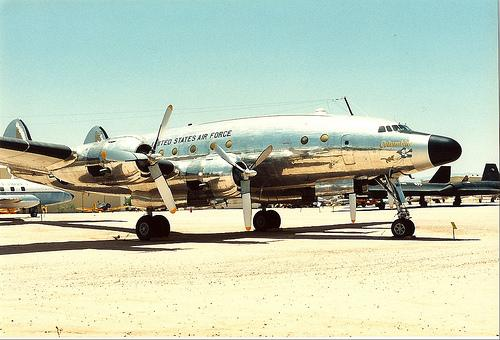What are the two main colors of the plane and where is the writing located on it? The plane is silver and black, with United States Air Force writing on the side. Describe the airplane's wheels and surrounding area. The airplane has black wheels with front and back landing gear, securely stopped on the dirt ground. How many propellers are visible on the airplane and where are they located? There are two propellers, one on the outside right and the other on the inside right side of the plane. What is distinctive about the airplane's engines and where are they located? The engines have propellers, located on the right side of the plane, with one being big and the other small. What is the main object in the image and what color is its nose? The main object is a United States Air Force plane and its nose is black. What is the position of the plane's front wheel and describe its appearance? The front wheel is at the plane's front under the landing gear and it is black. List three features found on the exterior of the airplane. Propellers, wheels with landing gear, and United States Air Force writing. Point out any distinct markings or graphics on the airplane's exterior. There's a logo of the pilot on the side, black United States Air Force writing, and a black nose. What is the purpose of the object in the image and can you identify its type? The purpose is transportation and military use, and it's an antique United States Air Force plane. Identify the location of the airplane and describe the background. The airplane is on the ground, outdoors with blue skies and buildings in the background. There's a purple jet in the foreground. Can you find it? There is a black jet mentioned in the details but not a purple jet, and it's in the background instead of the foreground. This instruction misleads with the wrong color and location of the jet. The airplane is parked in a lush, green field. The airplane is on the ground, but there's no mention of a lush, green field. This instruction includes false environmental details that may make it difficult for the reader to understand the actual context. Can you see the green nose cone on the airplane? The nose cone is actually mentioned to be black in the given details, not green. This instruction is misleading because it may confuse the reader by introducing a wrong color. Can you spot the red buildings in the background? There are buildings in the background but their color isn't mentioned, so adding a red color to them in the instruction would be misleading. Notice the orange airplane engine without a propeller. All airplane engines mentioned in the details have propellers, and none of them are described as orange. This instruction introduces wrong color and contradicts the presence of propellers. An airplane is flying overhead with red United States Air Force writing on its side. The airplane is on the ground and the United States Air Force writing is mentioned to be on the plane, but it is not mentioned to be red. This instruction is misleading in terms of the airplane's position and the color of the writing. Did you spot the yellow landing gear at the back of the plane? No, it's not mentioned in the image. Look for the large pink propeller on the left side of the plane. Both the small and big propellers are mentioned in the given details, but none of them are pink or located on the left side. This instruction is misleading as it introduces incorrect color and location. There is a cloudless, gray sky in the background. The sky is described as blue in the details, not gray, and it doesn't say anything about clouds. This instruction introduces wrong color and suggests an inaccurate weather condition. 